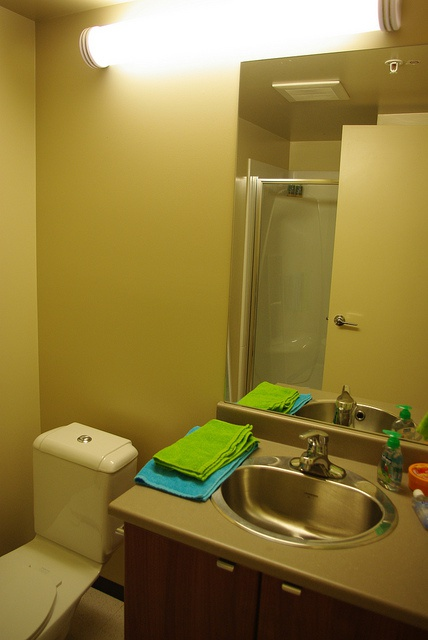Describe the objects in this image and their specific colors. I can see toilet in olive and tan tones, sink in olive and black tones, bottle in olive, black, and darkgreen tones, bottle in olive and black tones, and bottle in olive, gray, and tan tones in this image. 